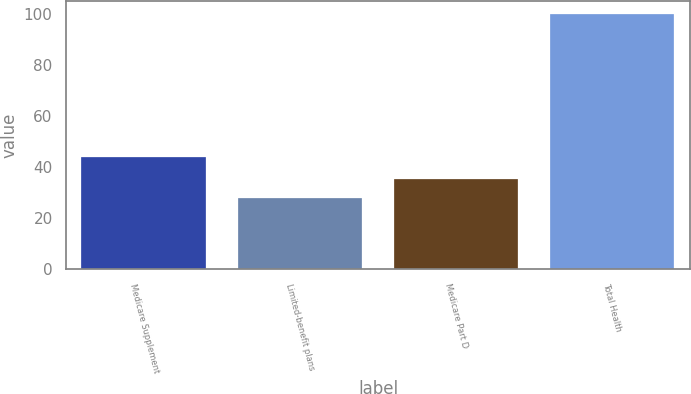Convert chart to OTSL. <chart><loc_0><loc_0><loc_500><loc_500><bar_chart><fcel>Medicare Supplement<fcel>Limited-benefit plans<fcel>Medicare Part D<fcel>Total Health<nl><fcel>44<fcel>28<fcel>35.2<fcel>100<nl></chart> 